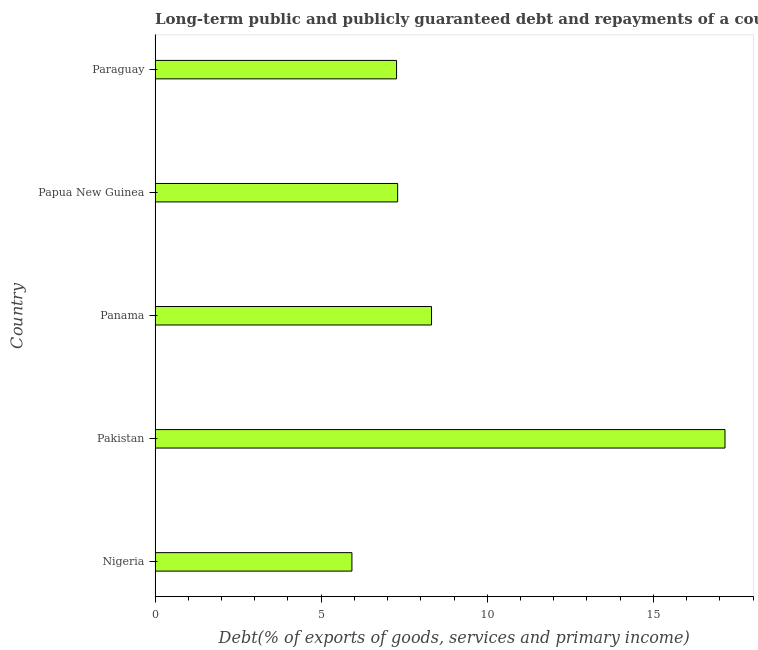Does the graph contain any zero values?
Keep it short and to the point. No. What is the title of the graph?
Make the answer very short. Long-term public and publicly guaranteed debt and repayments of a country to the IMF in 2003. What is the label or title of the X-axis?
Keep it short and to the point. Debt(% of exports of goods, services and primary income). What is the debt service in Nigeria?
Give a very brief answer. 5.93. Across all countries, what is the maximum debt service?
Your answer should be compact. 17.16. Across all countries, what is the minimum debt service?
Keep it short and to the point. 5.93. In which country was the debt service maximum?
Provide a short and direct response. Pakistan. In which country was the debt service minimum?
Ensure brevity in your answer.  Nigeria. What is the sum of the debt service?
Keep it short and to the point. 45.97. What is the average debt service per country?
Your answer should be compact. 9.2. What is the median debt service?
Make the answer very short. 7.3. What is the ratio of the debt service in Nigeria to that in Papua New Guinea?
Keep it short and to the point. 0.81. What is the difference between the highest and the second highest debt service?
Give a very brief answer. 8.83. Is the sum of the debt service in Pakistan and Panama greater than the maximum debt service across all countries?
Ensure brevity in your answer.  Yes. What is the difference between the highest and the lowest debt service?
Provide a succinct answer. 11.23. In how many countries, is the debt service greater than the average debt service taken over all countries?
Ensure brevity in your answer.  1. How many bars are there?
Offer a terse response. 5. Are all the bars in the graph horizontal?
Your answer should be compact. Yes. How many countries are there in the graph?
Offer a very short reply. 5. What is the difference between two consecutive major ticks on the X-axis?
Keep it short and to the point. 5. Are the values on the major ticks of X-axis written in scientific E-notation?
Your answer should be very brief. No. What is the Debt(% of exports of goods, services and primary income) in Nigeria?
Your answer should be compact. 5.93. What is the Debt(% of exports of goods, services and primary income) of Pakistan?
Provide a short and direct response. 17.16. What is the Debt(% of exports of goods, services and primary income) of Panama?
Offer a terse response. 8.32. What is the Debt(% of exports of goods, services and primary income) in Papua New Guinea?
Provide a succinct answer. 7.3. What is the Debt(% of exports of goods, services and primary income) in Paraguay?
Offer a terse response. 7.27. What is the difference between the Debt(% of exports of goods, services and primary income) in Nigeria and Pakistan?
Offer a terse response. -11.23. What is the difference between the Debt(% of exports of goods, services and primary income) in Nigeria and Panama?
Offer a very short reply. -2.4. What is the difference between the Debt(% of exports of goods, services and primary income) in Nigeria and Papua New Guinea?
Make the answer very short. -1.38. What is the difference between the Debt(% of exports of goods, services and primary income) in Nigeria and Paraguay?
Offer a very short reply. -1.34. What is the difference between the Debt(% of exports of goods, services and primary income) in Pakistan and Panama?
Provide a succinct answer. 8.83. What is the difference between the Debt(% of exports of goods, services and primary income) in Pakistan and Papua New Guinea?
Your response must be concise. 9.85. What is the difference between the Debt(% of exports of goods, services and primary income) in Pakistan and Paraguay?
Your answer should be very brief. 9.89. What is the difference between the Debt(% of exports of goods, services and primary income) in Panama and Papua New Guinea?
Your answer should be compact. 1.02. What is the difference between the Debt(% of exports of goods, services and primary income) in Panama and Paraguay?
Your response must be concise. 1.05. What is the difference between the Debt(% of exports of goods, services and primary income) in Papua New Guinea and Paraguay?
Offer a terse response. 0.03. What is the ratio of the Debt(% of exports of goods, services and primary income) in Nigeria to that in Pakistan?
Your answer should be very brief. 0.34. What is the ratio of the Debt(% of exports of goods, services and primary income) in Nigeria to that in Panama?
Provide a short and direct response. 0.71. What is the ratio of the Debt(% of exports of goods, services and primary income) in Nigeria to that in Papua New Guinea?
Your answer should be compact. 0.81. What is the ratio of the Debt(% of exports of goods, services and primary income) in Nigeria to that in Paraguay?
Your answer should be very brief. 0.81. What is the ratio of the Debt(% of exports of goods, services and primary income) in Pakistan to that in Panama?
Your answer should be very brief. 2.06. What is the ratio of the Debt(% of exports of goods, services and primary income) in Pakistan to that in Papua New Guinea?
Ensure brevity in your answer.  2.35. What is the ratio of the Debt(% of exports of goods, services and primary income) in Pakistan to that in Paraguay?
Make the answer very short. 2.36. What is the ratio of the Debt(% of exports of goods, services and primary income) in Panama to that in Papua New Guinea?
Offer a terse response. 1.14. What is the ratio of the Debt(% of exports of goods, services and primary income) in Panama to that in Paraguay?
Ensure brevity in your answer.  1.15. What is the ratio of the Debt(% of exports of goods, services and primary income) in Papua New Guinea to that in Paraguay?
Provide a short and direct response. 1. 